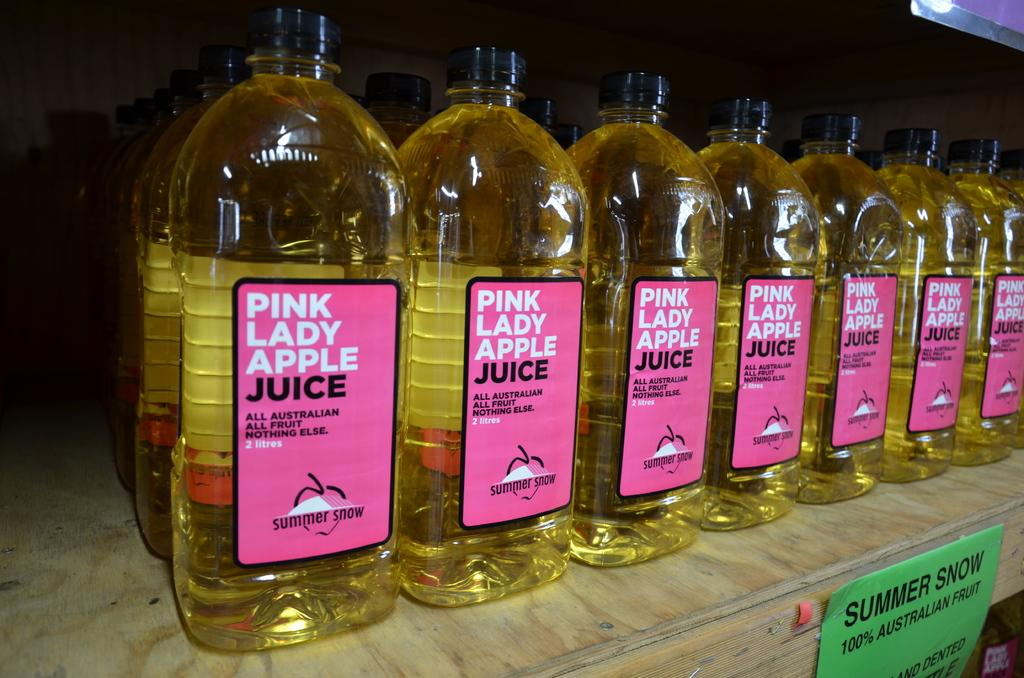<image>
Provide a brief description of the given image. Bottles of Pink Lady Apple juice are lined up in a row. 